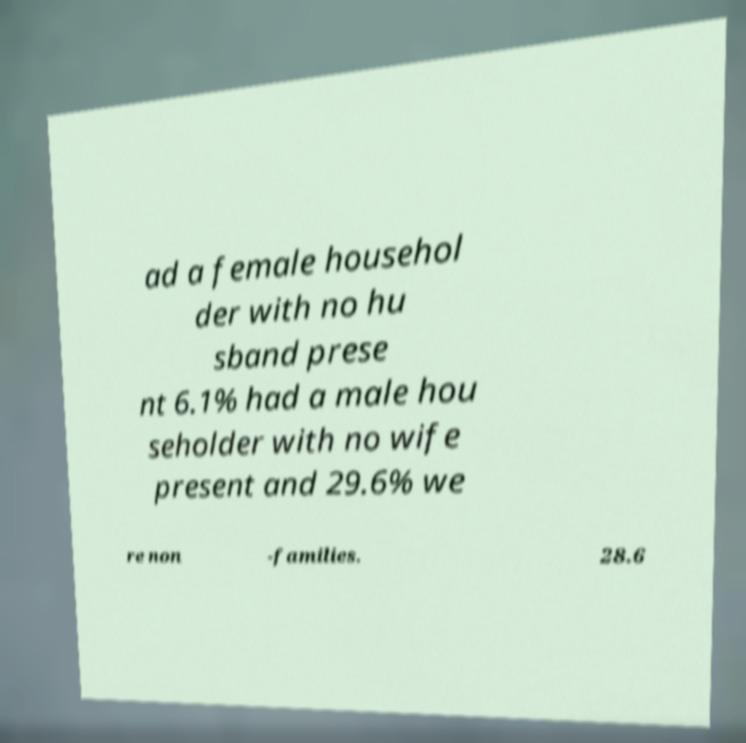For documentation purposes, I need the text within this image transcribed. Could you provide that? ad a female househol der with no hu sband prese nt 6.1% had a male hou seholder with no wife present and 29.6% we re non -families. 28.6 